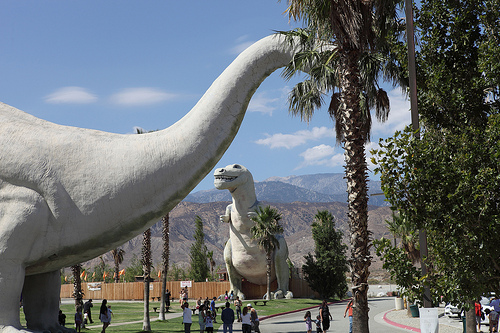<image>
Is there a dinosaur behind the palm tree? Yes. From this viewpoint, the dinosaur is positioned behind the palm tree, with the palm tree partially or fully occluding the dinosaur. Is the person in front of the tree? No. The person is not in front of the tree. The spatial positioning shows a different relationship between these objects. 